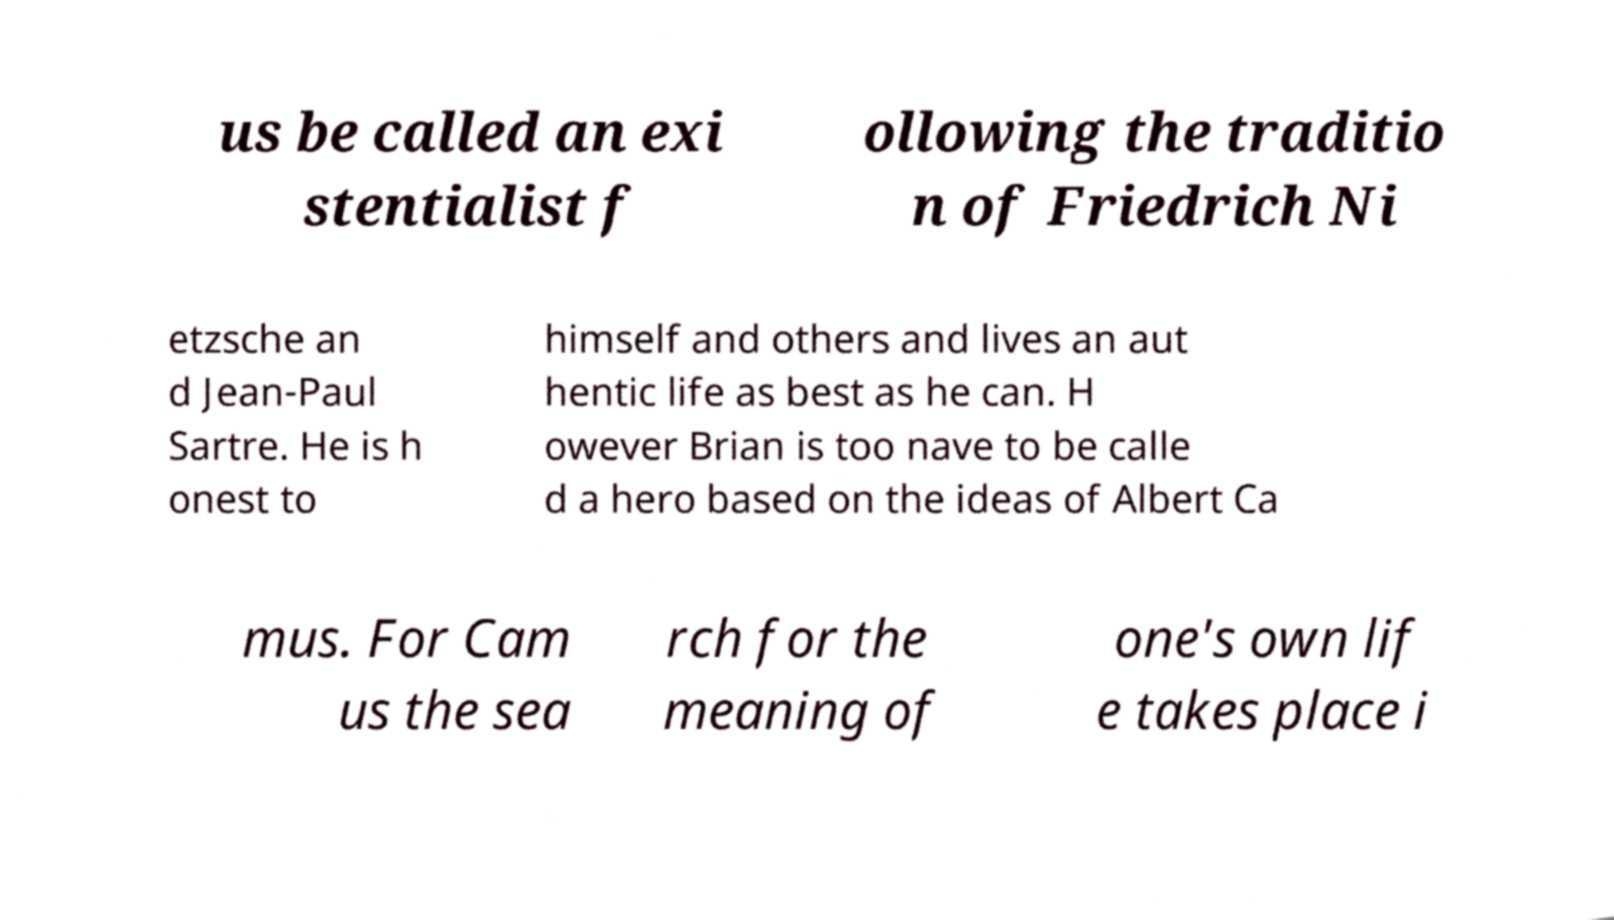For documentation purposes, I need the text within this image transcribed. Could you provide that? us be called an exi stentialist f ollowing the traditio n of Friedrich Ni etzsche an d Jean-Paul Sartre. He is h onest to himself and others and lives an aut hentic life as best as he can. H owever Brian is too nave to be calle d a hero based on the ideas of Albert Ca mus. For Cam us the sea rch for the meaning of one's own lif e takes place i 